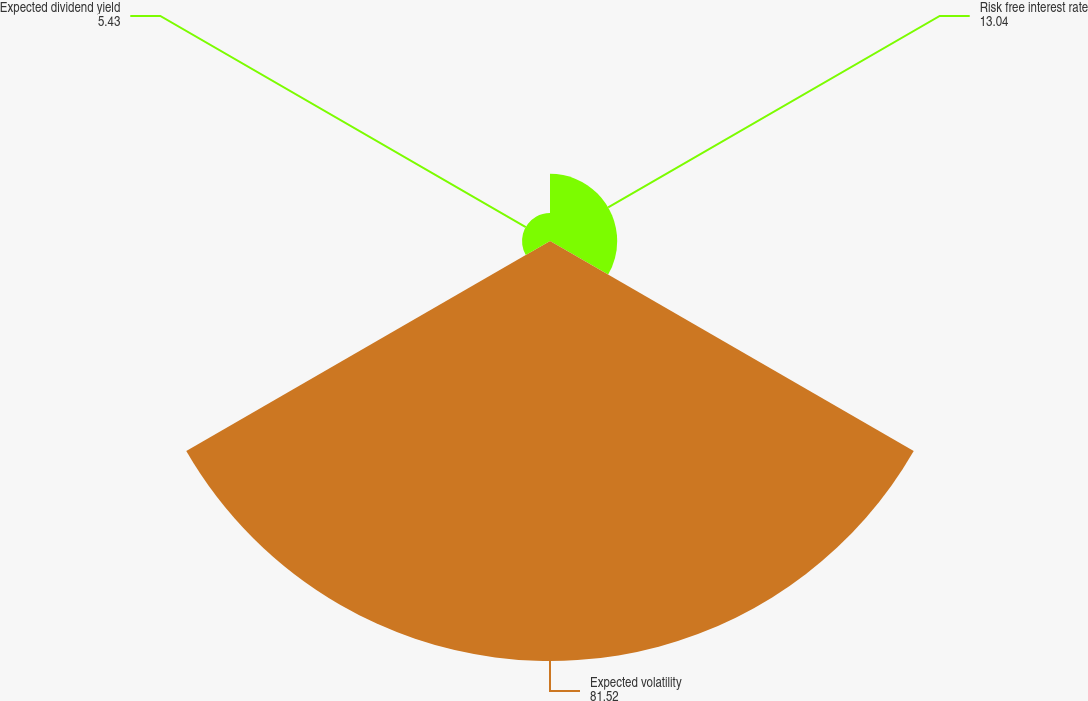Convert chart. <chart><loc_0><loc_0><loc_500><loc_500><pie_chart><fcel>Risk free interest rate<fcel>Expected volatility<fcel>Expected dividend yield<nl><fcel>13.04%<fcel>81.52%<fcel>5.43%<nl></chart> 